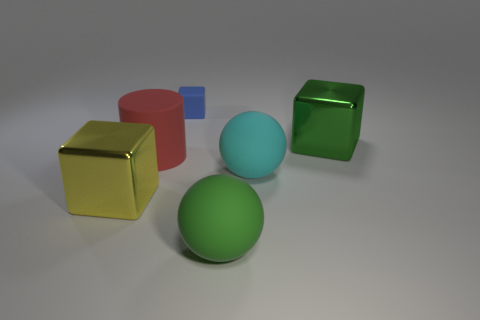There is a large cylinder that is the same material as the large cyan ball; what is its color? The large cylinder does not appear in the image you provided. However, if it were present and made of the same material as the large cyan ball, it would likely be cyan as well. 